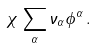<formula> <loc_0><loc_0><loc_500><loc_500>\chi \, \sum _ { \alpha } \nu _ { \alpha } \phi ^ { \alpha } \, .</formula> 